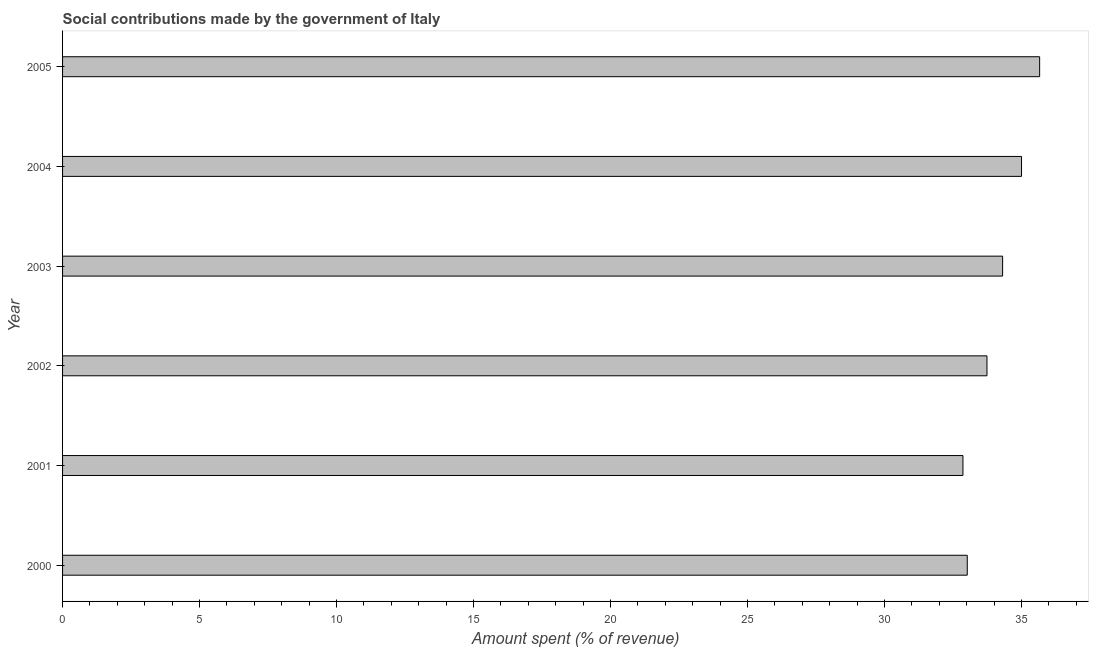Does the graph contain any zero values?
Offer a very short reply. No. Does the graph contain grids?
Give a very brief answer. No. What is the title of the graph?
Make the answer very short. Social contributions made by the government of Italy. What is the label or title of the X-axis?
Ensure brevity in your answer.  Amount spent (% of revenue). What is the label or title of the Y-axis?
Provide a short and direct response. Year. What is the amount spent in making social contributions in 2004?
Provide a succinct answer. 35. Across all years, what is the maximum amount spent in making social contributions?
Provide a short and direct response. 35.67. Across all years, what is the minimum amount spent in making social contributions?
Your response must be concise. 32.87. What is the sum of the amount spent in making social contributions?
Your answer should be compact. 204.62. What is the difference between the amount spent in making social contributions in 2001 and 2004?
Provide a succinct answer. -2.14. What is the average amount spent in making social contributions per year?
Offer a terse response. 34.1. What is the median amount spent in making social contributions?
Offer a very short reply. 34.03. Do a majority of the years between 2002 and 2004 (inclusive) have amount spent in making social contributions greater than 34 %?
Keep it short and to the point. Yes. Is the amount spent in making social contributions in 2000 less than that in 2004?
Your answer should be very brief. Yes. Is the difference between the amount spent in making social contributions in 2001 and 2004 greater than the difference between any two years?
Keep it short and to the point. No. What is the difference between the highest and the second highest amount spent in making social contributions?
Provide a short and direct response. 0.66. What is the difference between the highest and the lowest amount spent in making social contributions?
Keep it short and to the point. 2.8. In how many years, is the amount spent in making social contributions greater than the average amount spent in making social contributions taken over all years?
Your response must be concise. 3. How many bars are there?
Give a very brief answer. 6. What is the Amount spent (% of revenue) in 2000?
Make the answer very short. 33.02. What is the Amount spent (% of revenue) of 2001?
Give a very brief answer. 32.87. What is the Amount spent (% of revenue) of 2002?
Your response must be concise. 33.74. What is the Amount spent (% of revenue) of 2003?
Your answer should be compact. 34.31. What is the Amount spent (% of revenue) of 2004?
Provide a short and direct response. 35. What is the Amount spent (% of revenue) of 2005?
Keep it short and to the point. 35.67. What is the difference between the Amount spent (% of revenue) in 2000 and 2001?
Your answer should be compact. 0.16. What is the difference between the Amount spent (% of revenue) in 2000 and 2002?
Provide a short and direct response. -0.72. What is the difference between the Amount spent (% of revenue) in 2000 and 2003?
Ensure brevity in your answer.  -1.29. What is the difference between the Amount spent (% of revenue) in 2000 and 2004?
Your answer should be compact. -1.98. What is the difference between the Amount spent (% of revenue) in 2000 and 2005?
Ensure brevity in your answer.  -2.64. What is the difference between the Amount spent (% of revenue) in 2001 and 2002?
Ensure brevity in your answer.  -0.88. What is the difference between the Amount spent (% of revenue) in 2001 and 2003?
Your answer should be compact. -1.45. What is the difference between the Amount spent (% of revenue) in 2001 and 2004?
Offer a terse response. -2.14. What is the difference between the Amount spent (% of revenue) in 2001 and 2005?
Give a very brief answer. -2.8. What is the difference between the Amount spent (% of revenue) in 2002 and 2003?
Offer a very short reply. -0.57. What is the difference between the Amount spent (% of revenue) in 2002 and 2004?
Provide a short and direct response. -1.26. What is the difference between the Amount spent (% of revenue) in 2002 and 2005?
Keep it short and to the point. -1.92. What is the difference between the Amount spent (% of revenue) in 2003 and 2004?
Ensure brevity in your answer.  -0.69. What is the difference between the Amount spent (% of revenue) in 2003 and 2005?
Provide a short and direct response. -1.35. What is the difference between the Amount spent (% of revenue) in 2004 and 2005?
Your answer should be compact. -0.66. What is the ratio of the Amount spent (% of revenue) in 2000 to that in 2001?
Ensure brevity in your answer.  1. What is the ratio of the Amount spent (% of revenue) in 2000 to that in 2002?
Your answer should be very brief. 0.98. What is the ratio of the Amount spent (% of revenue) in 2000 to that in 2004?
Provide a succinct answer. 0.94. What is the ratio of the Amount spent (% of revenue) in 2000 to that in 2005?
Give a very brief answer. 0.93. What is the ratio of the Amount spent (% of revenue) in 2001 to that in 2002?
Give a very brief answer. 0.97. What is the ratio of the Amount spent (% of revenue) in 2001 to that in 2003?
Your response must be concise. 0.96. What is the ratio of the Amount spent (% of revenue) in 2001 to that in 2004?
Provide a succinct answer. 0.94. What is the ratio of the Amount spent (% of revenue) in 2001 to that in 2005?
Provide a succinct answer. 0.92. What is the ratio of the Amount spent (% of revenue) in 2002 to that in 2003?
Make the answer very short. 0.98. What is the ratio of the Amount spent (% of revenue) in 2002 to that in 2005?
Make the answer very short. 0.95. What is the ratio of the Amount spent (% of revenue) in 2003 to that in 2005?
Your response must be concise. 0.96. 